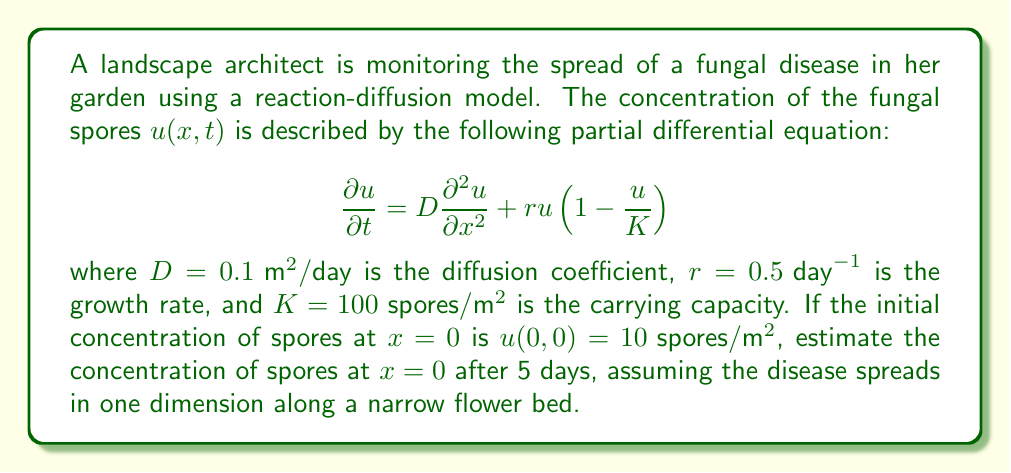Help me with this question. To solve this problem, we need to use the given reaction-diffusion equation and apply it to our specific scenario. Let's break it down step-by-step:

1) The equation we're working with is:

   $$\frac{\partial u}{\partial t} = D\frac{\partial^2 u}{\partial x^2} + ru(1-\frac{u}{K})$$

2) We're interested in the concentration at $x=0$ over time, so we can simplify our problem by considering only the time-dependent part of the equation at $x=0$:

   $$\frac{du}{dt} = ru(1-\frac{u}{K})$$

   This is because at $x=0$, the spatial derivative term $\frac{\partial^2 u}{\partial x^2}$ becomes zero.

3) This simplified equation is the logistic growth equation, which has the solution:

   $$u(t) = \frac{K}{1 + (\frac{K}{u_0} - 1)e^{-rt}}$$

   where $u_0$ is the initial concentration.

4) Now, let's plug in our values:
   - $K = 100 \text{ spores}/\text{m}^2$
   - $r = 0.5 \text{ day}^{-1$
   - $u_0 = 10 \text{ spores}/\text{m}^2$
   - $t = 5 \text{ days}$

5) Substituting these into our equation:

   $$u(5) = \frac{100}{1 + (\frac{100}{10} - 1)e^{-0.5 \cdot 5}}$$

6) Simplifying:
   
   $$u(5) = \frac{100}{1 + 9e^{-2.5}} \approx 71.53 \text{ spores}/\text{m}^2$$

Therefore, after 5 days, the concentration of spores at $x=0$ is approximately 71.53 spores/m².
Answer: $71.53 \text{ spores}/\text{m}^2$ 